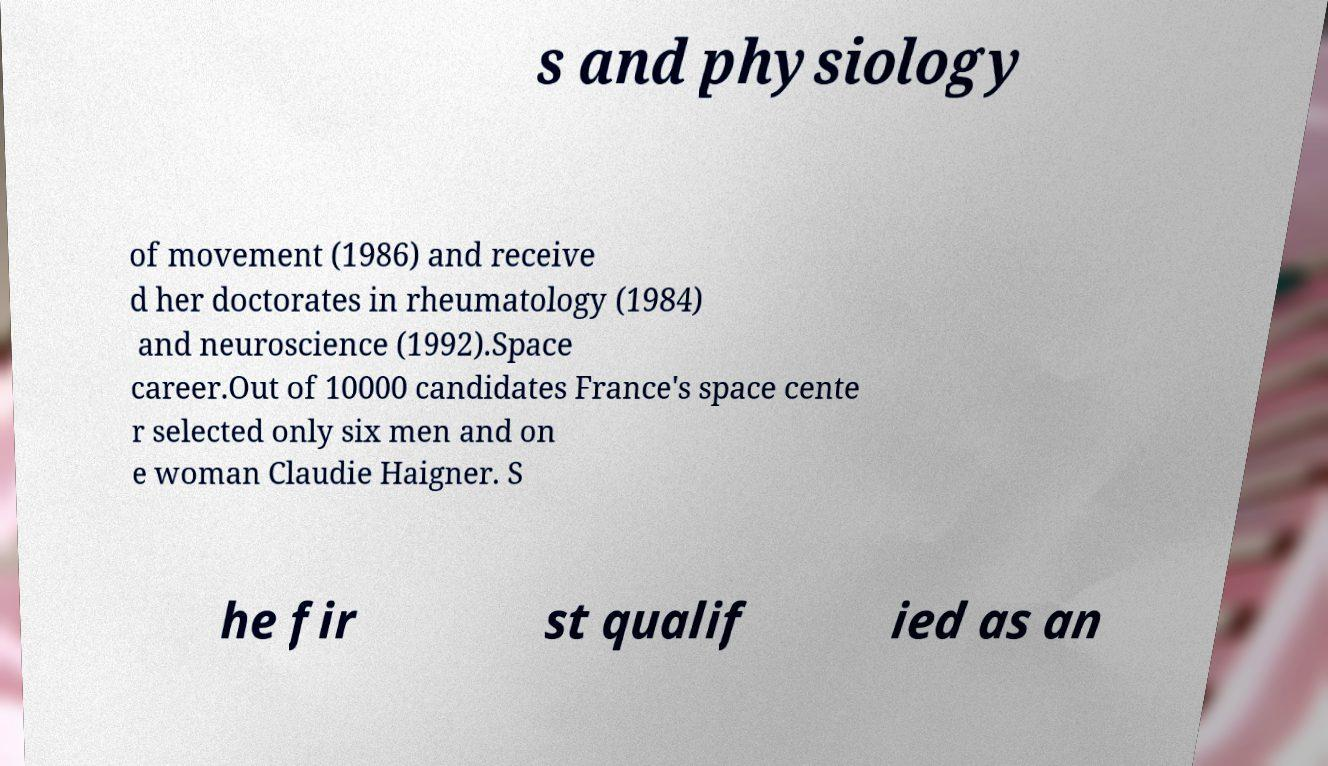Please read and relay the text visible in this image. What does it say? s and physiology of movement (1986) and receive d her doctorates in rheumatology (1984) and neuroscience (1992).Space career.Out of 10000 candidates France's space cente r selected only six men and on e woman Claudie Haigner. S he fir st qualif ied as an 